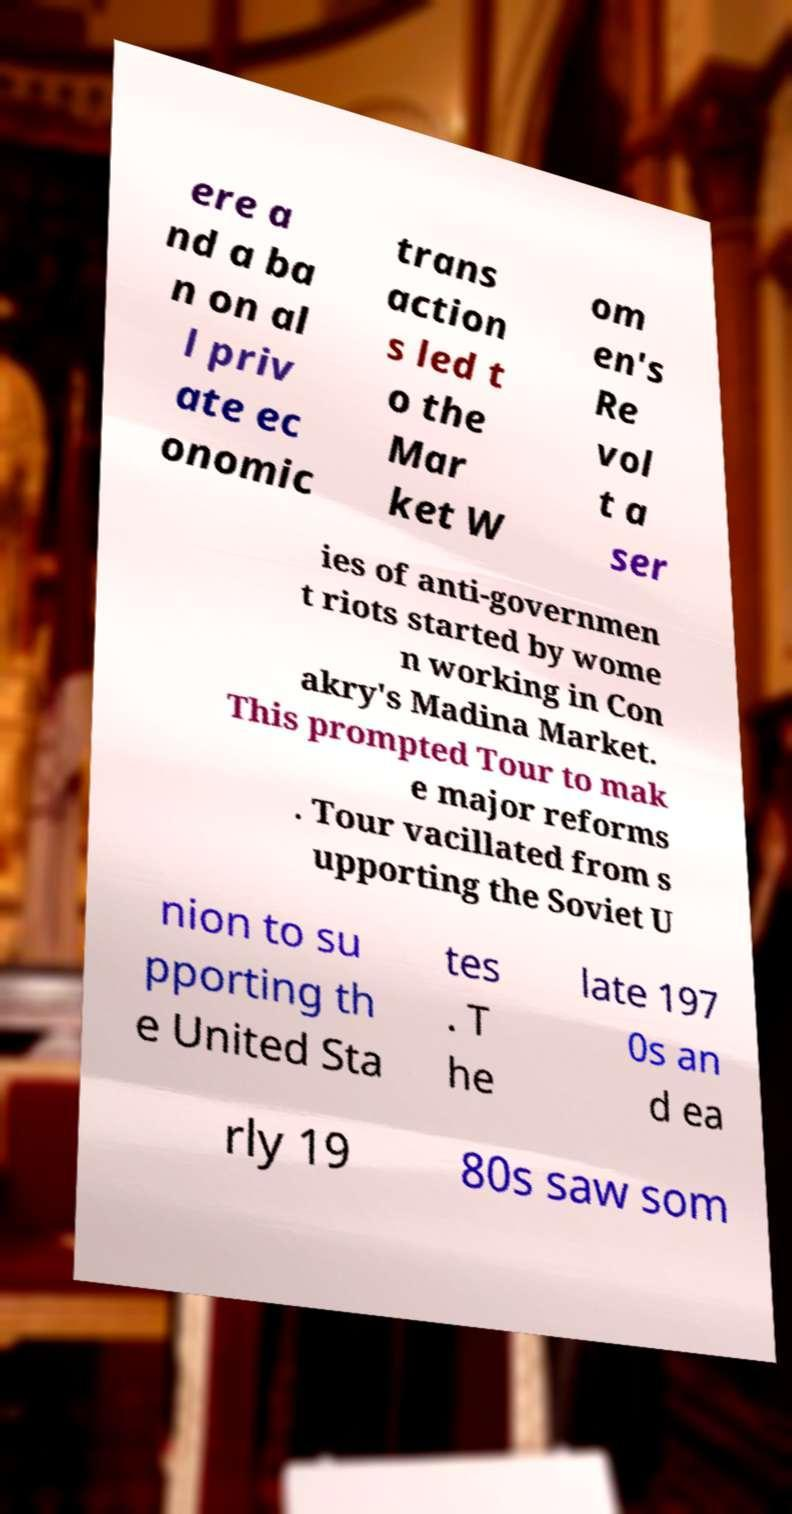What messages or text are displayed in this image? I need them in a readable, typed format. ere a nd a ba n on al l priv ate ec onomic trans action s led t o the Mar ket W om en's Re vol t a ser ies of anti-governmen t riots started by wome n working in Con akry's Madina Market. This prompted Tour to mak e major reforms . Tour vacillated from s upporting the Soviet U nion to su pporting th e United Sta tes . T he late 197 0s an d ea rly 19 80s saw som 